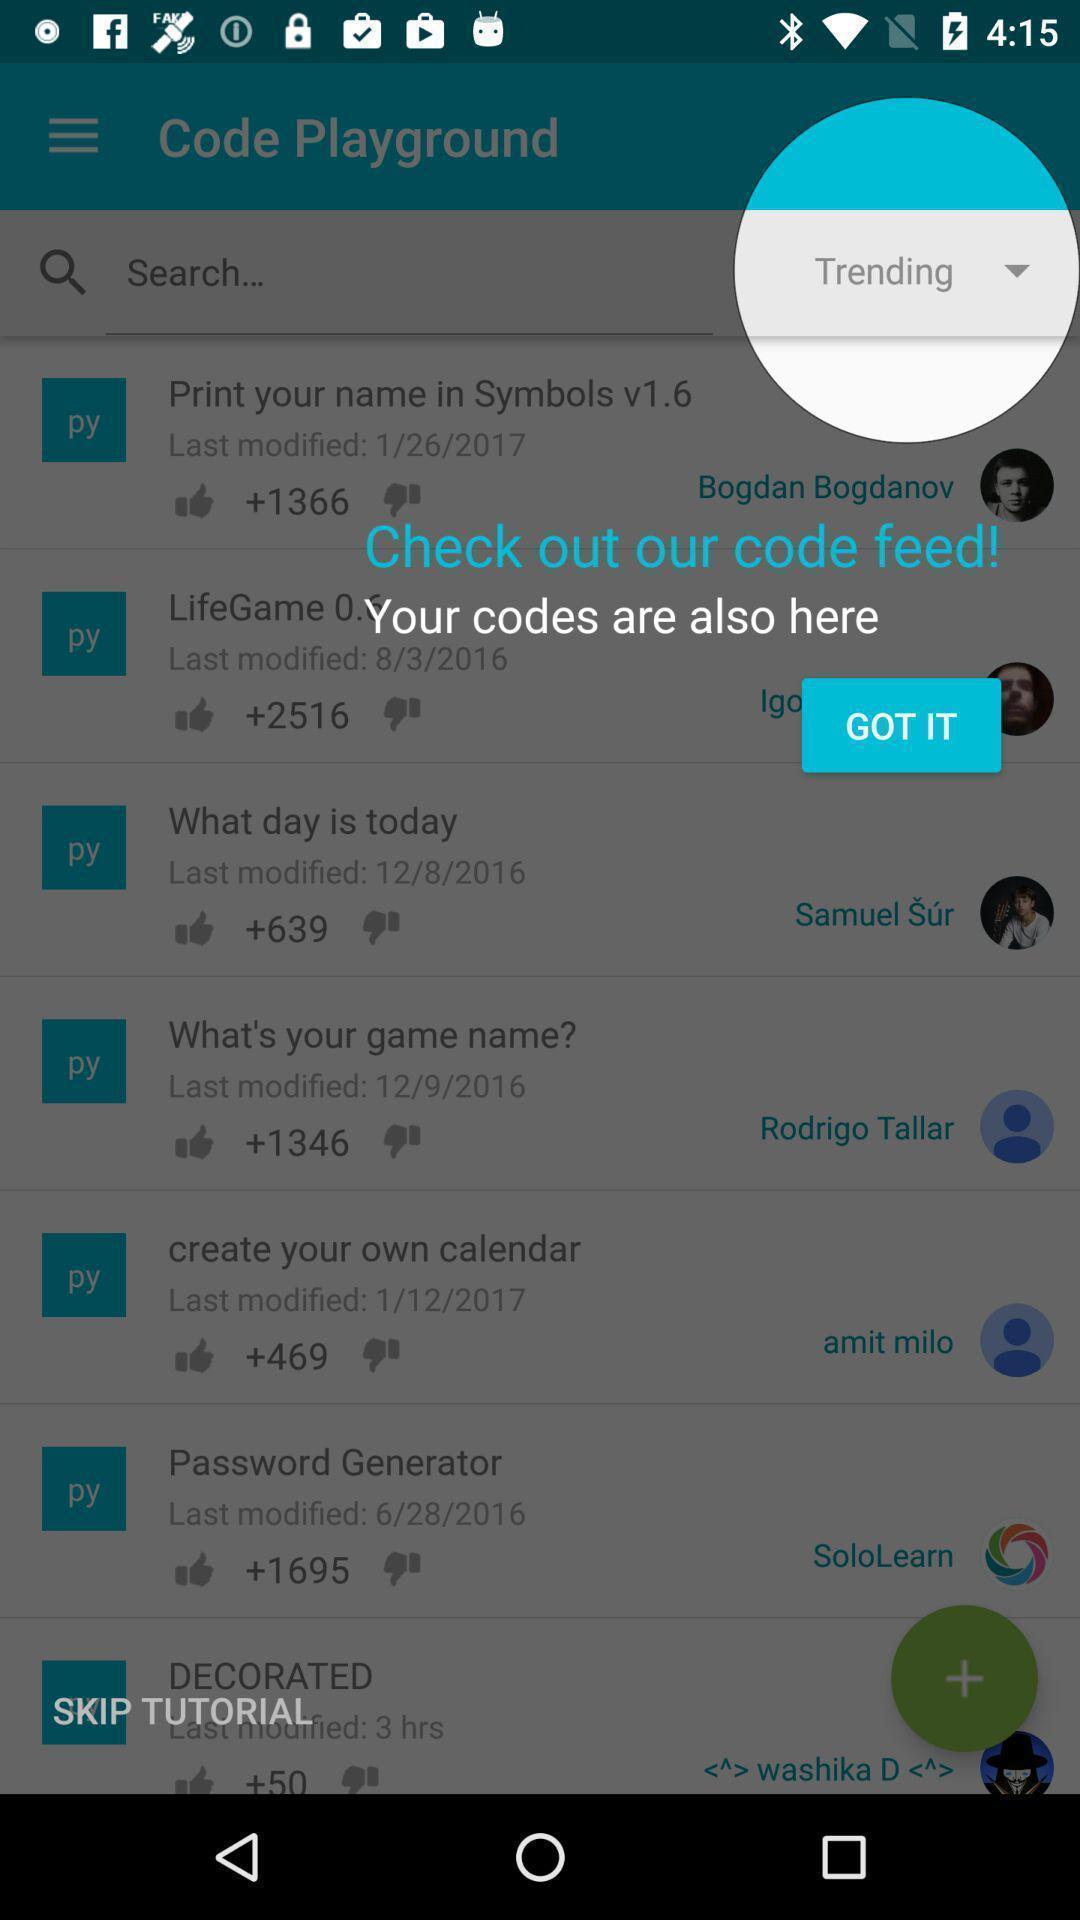Summarize the information in this screenshot. Pop-up shows code feed details in a learning app. 